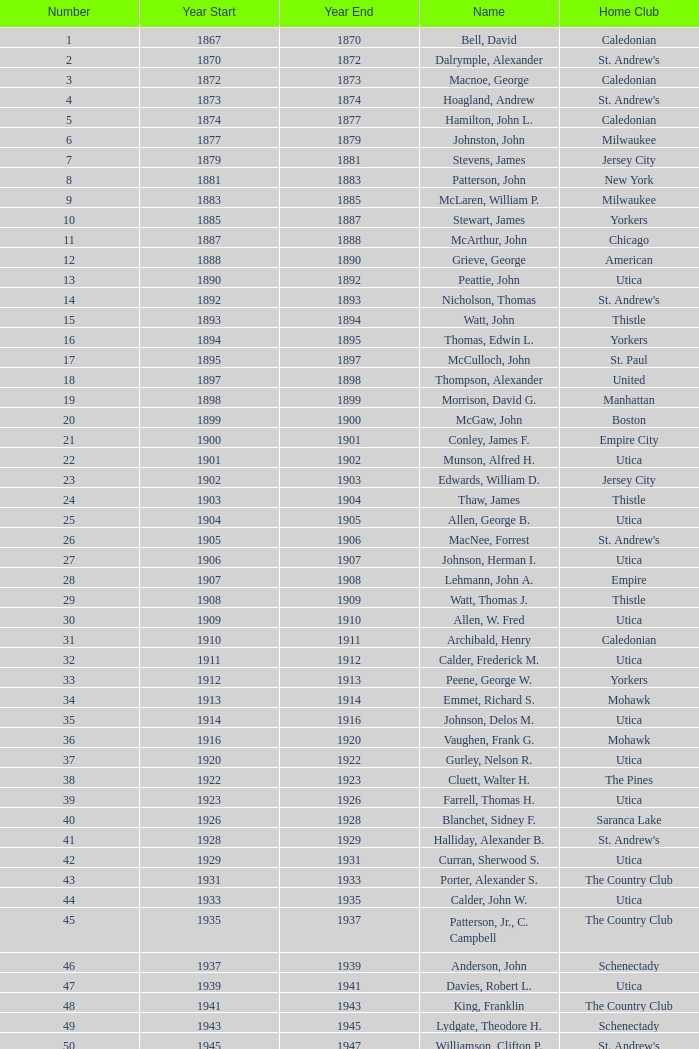In which year is the initial number 28? 1907.0. 